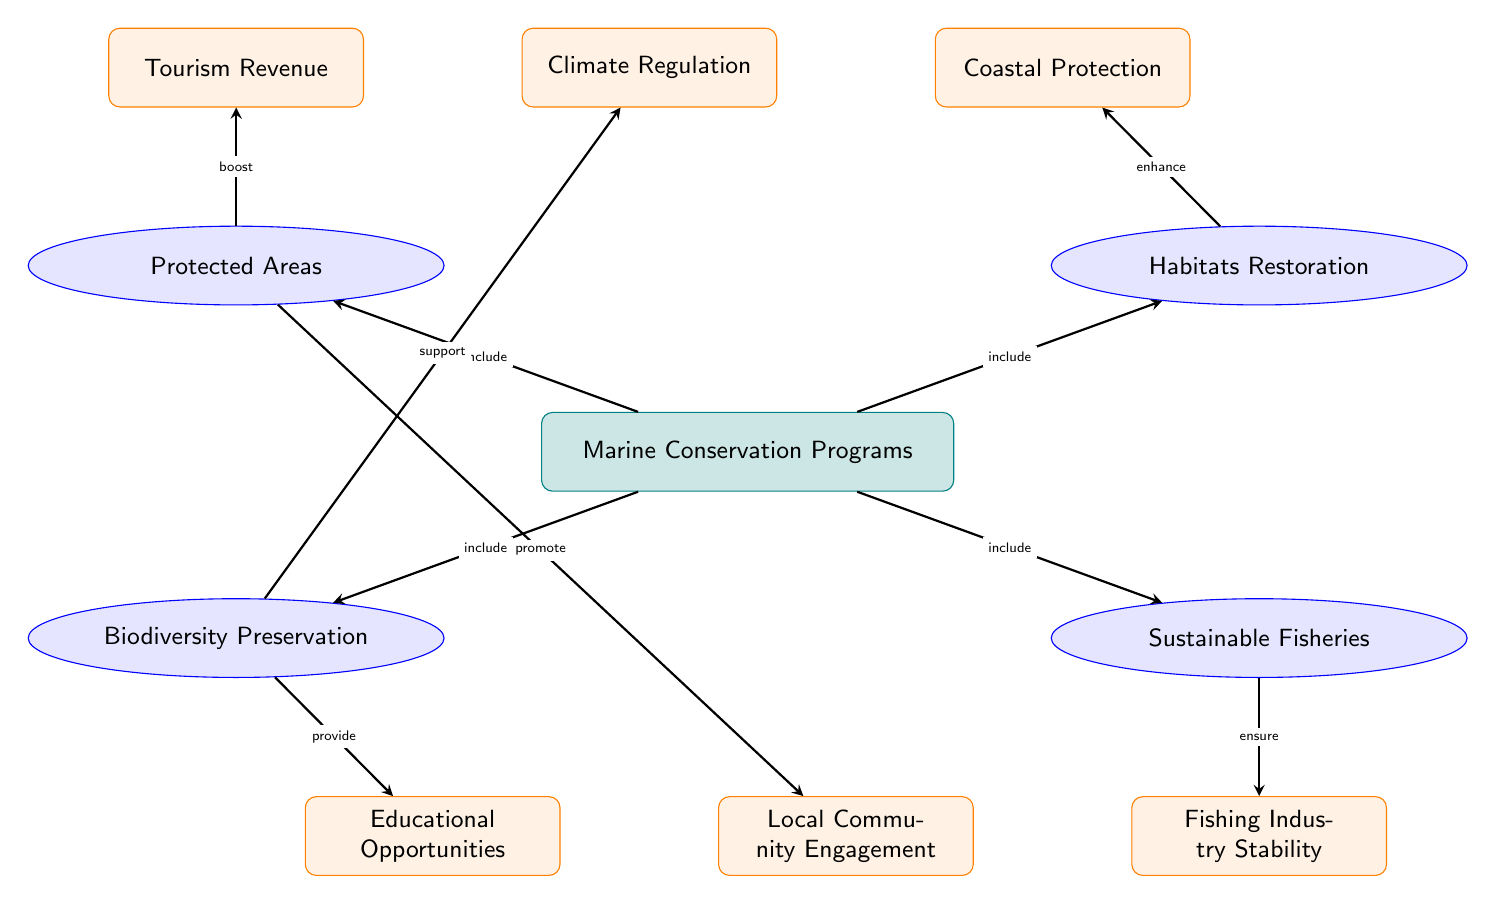What is the main topic depicted in the diagram? The main topic is represented by the central node labeled "Marine Conservation Programs." It establishes the main focus of the diagram, as it is the node from which all other subtopics and benefits are connected.
Answer: Marine Conservation Programs How many sub-topics are present in the diagram? The diagram shows four sub-topics, each branching out from the main topic: Protected Areas, Habitats Restoration, Biodiversity Preservation, and Sustainable Fisheries. This count is obtained by identifying individual nodes that are directly connected to the main topic.
Answer: 4 What benefit is connected to Protected Areas? The benefit connected to Protected Areas is "Tourism Revenue," which is depicted directly above the Protected Areas node in the diagram, showing a supportive relationship.
Answer: Tourism Revenue Which benefit is linked to Biodiversity Preservation? The benefit linked to Biodiversity Preservation is "Climate Regulation," as indicated by the arrow that connects these two nodes. This shows that the preservation of biodiversity supports climate regulation efforts.
Answer: Climate Regulation Which two sub-topics are related to the benefit of Coastal Protection? The sub-topic related to Coastal Protection is "Habitats Restoration." The diagram shows that Habitat Restoration enhances Coastal Protection, indicating a direct relationship between these two elements.
Answer: Habitats Restoration Which benefit promotes Local Community Engagement? The benefit that promotes Local Community Engagement is directly linked from the Protected Areas sub-topic. This means that initiatives related to Protected Areas encourage active engagement from local communities.
Answer: Protected Areas What is the relationship between Fisheries and Fishing Industry Stability? The relationship depicted between Fisheries and Fishing Industry Stability is that sustainable fisheries ensure stability in the fishing industry, as shown in the diagram by the arrow pointing from Fisheries to Fishing Industry Stability.
Answer: Ensure How does Biodiversity Preservation provide Educational Opportunities? Biodiversity Preservation provides Educational Opportunities through a direct connection in the diagram, where an arrow indicates that efforts to preserve biodiversity lead to more educational initiatives. This highlights the role of biodiversity in facilitating learning and awareness.
Answer: Provide What type of benefits can arise from the Protected Areas sub-topic? The types of benefits that arise from Protected Areas are "Tourism Revenue" and "Local Community Engagement," which are both connected directly through arrows leading from the Protected Areas sub-topic. This indicates the multifaceted impact of protected area initiatives.
Answer: Tourism Revenue, Local Community Engagement 